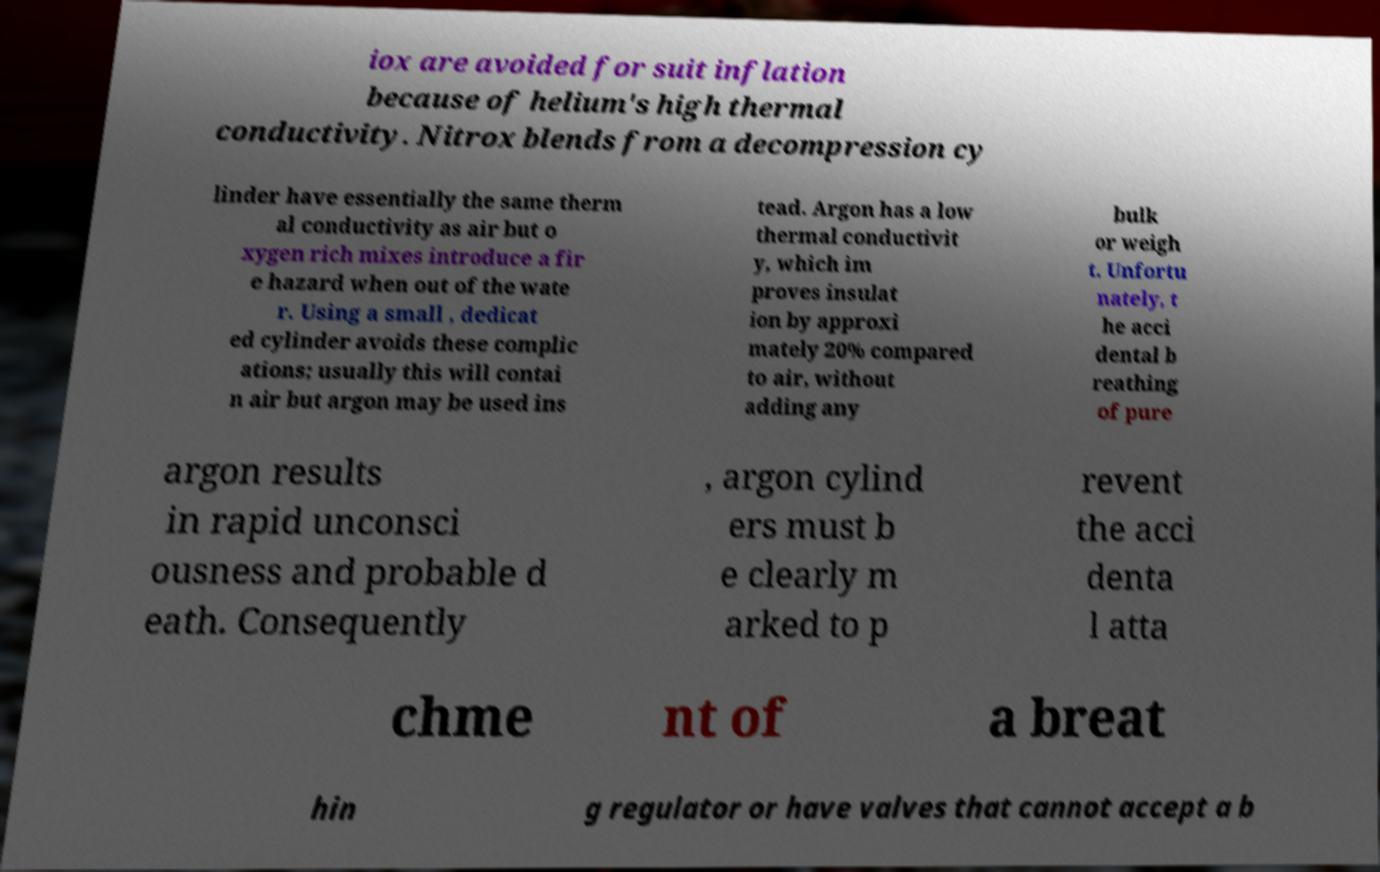I need the written content from this picture converted into text. Can you do that? iox are avoided for suit inflation because of helium's high thermal conductivity. Nitrox blends from a decompression cy linder have essentially the same therm al conductivity as air but o xygen rich mixes introduce a fir e hazard when out of the wate r. Using a small , dedicat ed cylinder avoids these complic ations; usually this will contai n air but argon may be used ins tead. Argon has a low thermal conductivit y, which im proves insulat ion by approxi mately 20% compared to air, without adding any bulk or weigh t. Unfortu nately, t he acci dental b reathing of pure argon results in rapid unconsci ousness and probable d eath. Consequently , argon cylind ers must b e clearly m arked to p revent the acci denta l atta chme nt of a breat hin g regulator or have valves that cannot accept a b 